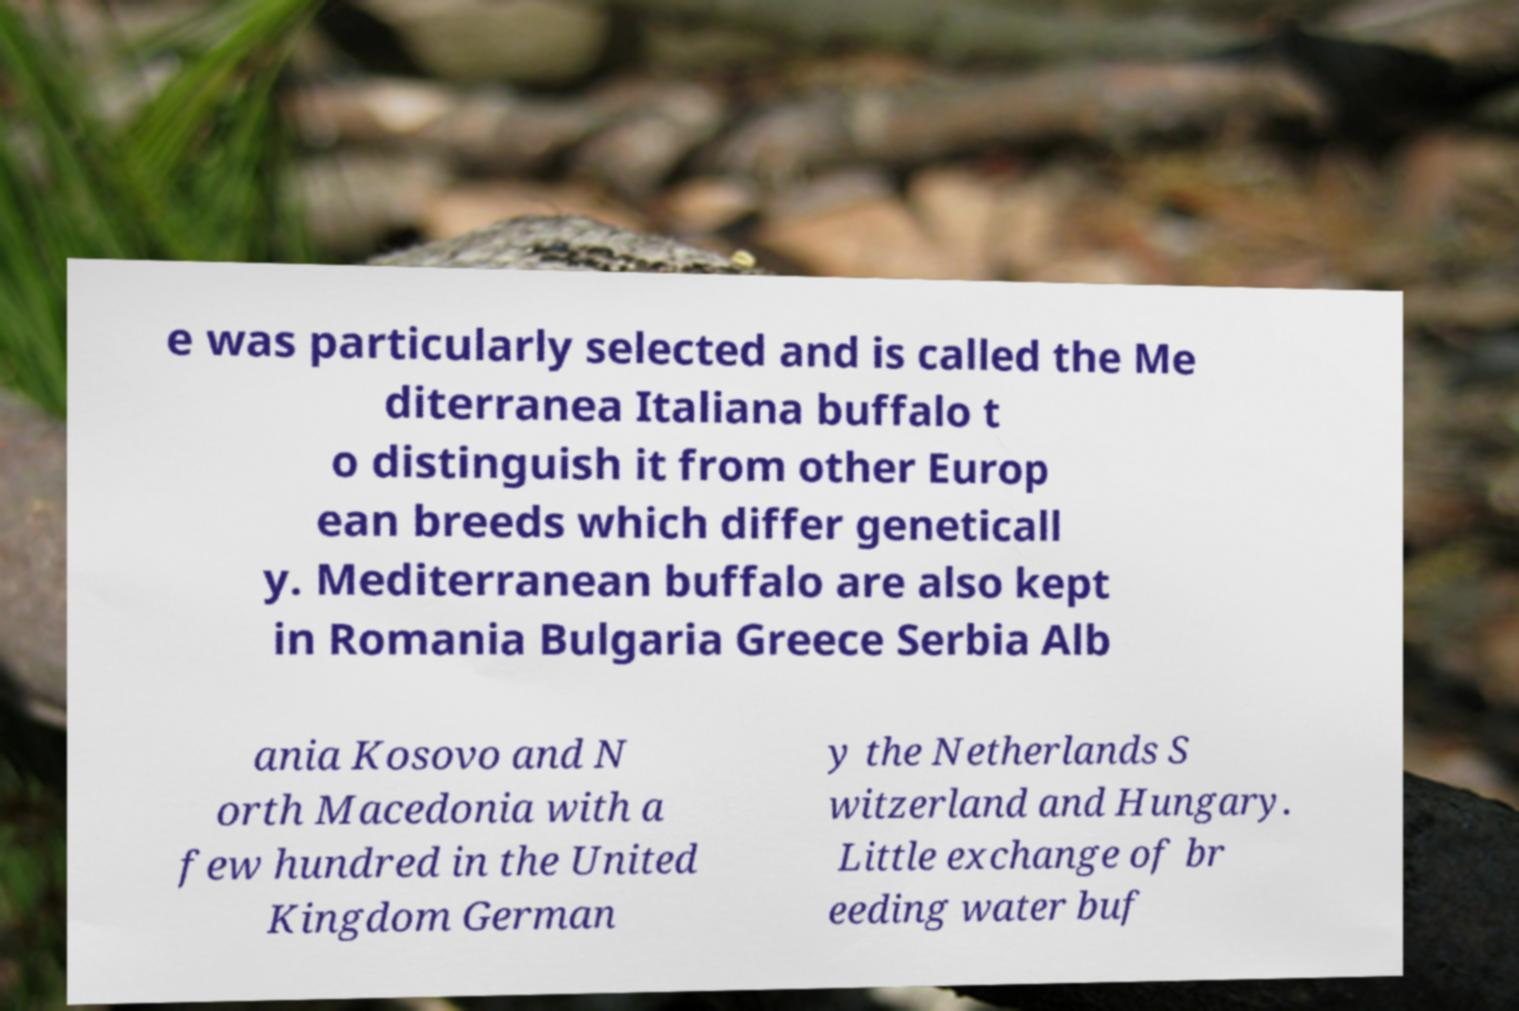For documentation purposes, I need the text within this image transcribed. Could you provide that? e was particularly selected and is called the Me diterranea Italiana buffalo t o distinguish it from other Europ ean breeds which differ geneticall y. Mediterranean buffalo are also kept in Romania Bulgaria Greece Serbia Alb ania Kosovo and N orth Macedonia with a few hundred in the United Kingdom German y the Netherlands S witzerland and Hungary. Little exchange of br eeding water buf 